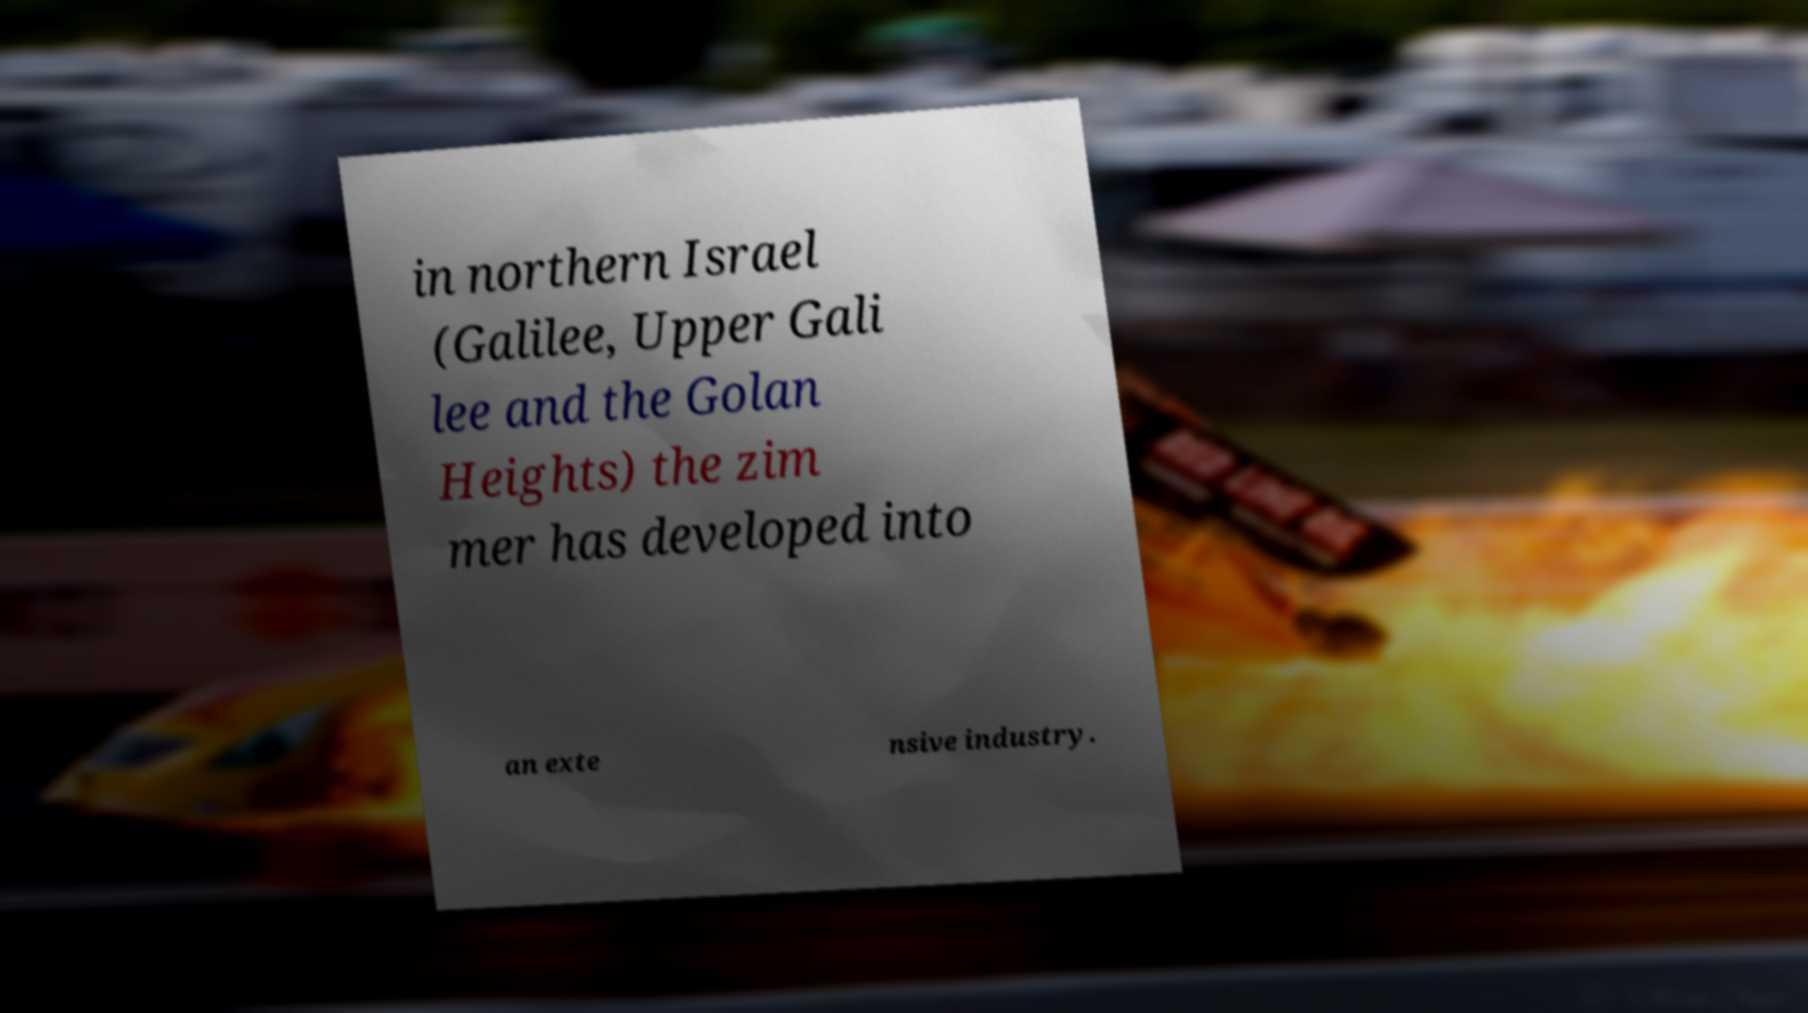What messages or text are displayed in this image? I need them in a readable, typed format. in northern Israel (Galilee, Upper Gali lee and the Golan Heights) the zim mer has developed into an exte nsive industry. 